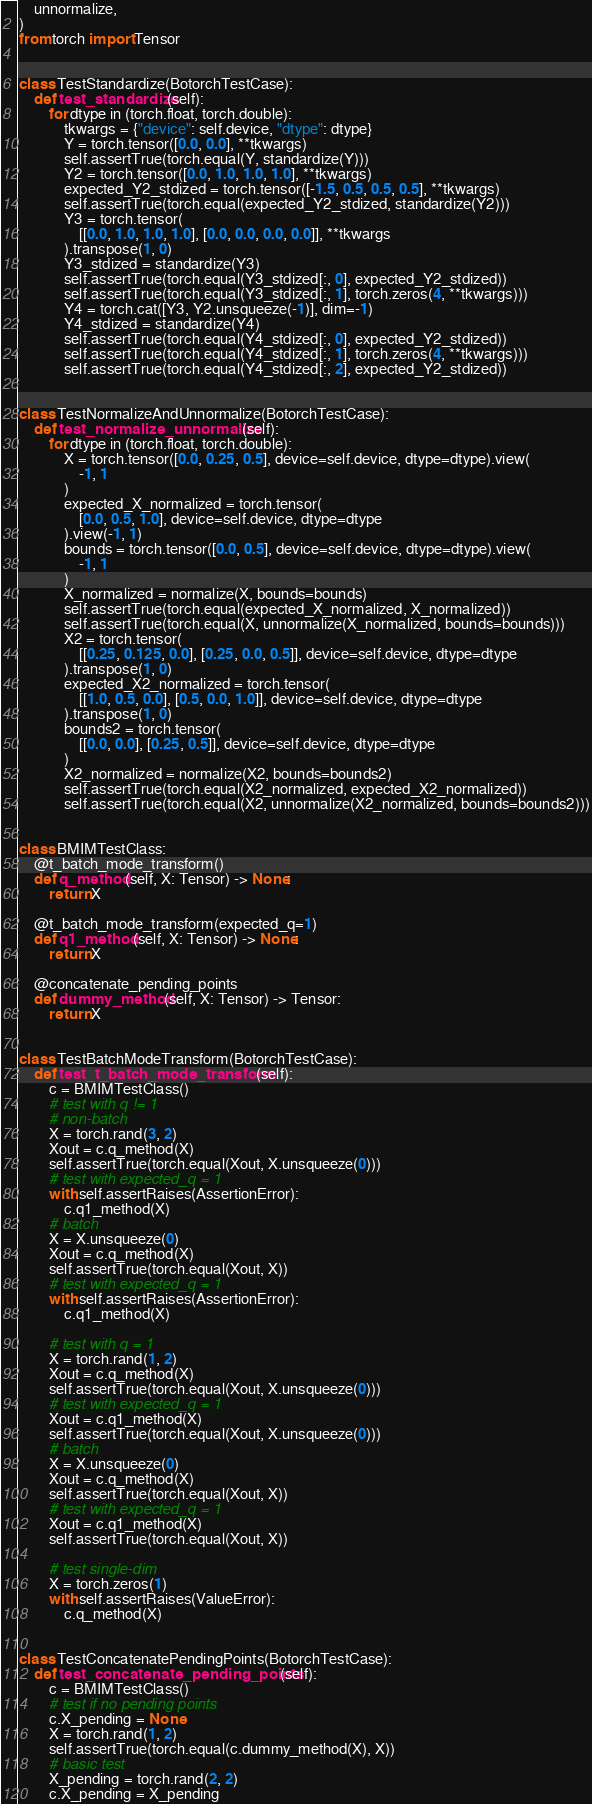Convert code to text. <code><loc_0><loc_0><loc_500><loc_500><_Python_>    unnormalize,
)
from torch import Tensor


class TestStandardize(BotorchTestCase):
    def test_standardize(self):
        for dtype in (torch.float, torch.double):
            tkwargs = {"device": self.device, "dtype": dtype}
            Y = torch.tensor([0.0, 0.0], **tkwargs)
            self.assertTrue(torch.equal(Y, standardize(Y)))
            Y2 = torch.tensor([0.0, 1.0, 1.0, 1.0], **tkwargs)
            expected_Y2_stdized = torch.tensor([-1.5, 0.5, 0.5, 0.5], **tkwargs)
            self.assertTrue(torch.equal(expected_Y2_stdized, standardize(Y2)))
            Y3 = torch.tensor(
                [[0.0, 1.0, 1.0, 1.0], [0.0, 0.0, 0.0, 0.0]], **tkwargs
            ).transpose(1, 0)
            Y3_stdized = standardize(Y3)
            self.assertTrue(torch.equal(Y3_stdized[:, 0], expected_Y2_stdized))
            self.assertTrue(torch.equal(Y3_stdized[:, 1], torch.zeros(4, **tkwargs)))
            Y4 = torch.cat([Y3, Y2.unsqueeze(-1)], dim=-1)
            Y4_stdized = standardize(Y4)
            self.assertTrue(torch.equal(Y4_stdized[:, 0], expected_Y2_stdized))
            self.assertTrue(torch.equal(Y4_stdized[:, 1], torch.zeros(4, **tkwargs)))
            self.assertTrue(torch.equal(Y4_stdized[:, 2], expected_Y2_stdized))


class TestNormalizeAndUnnormalize(BotorchTestCase):
    def test_normalize_unnormalize(self):
        for dtype in (torch.float, torch.double):
            X = torch.tensor([0.0, 0.25, 0.5], device=self.device, dtype=dtype).view(
                -1, 1
            )
            expected_X_normalized = torch.tensor(
                [0.0, 0.5, 1.0], device=self.device, dtype=dtype
            ).view(-1, 1)
            bounds = torch.tensor([0.0, 0.5], device=self.device, dtype=dtype).view(
                -1, 1
            )
            X_normalized = normalize(X, bounds=bounds)
            self.assertTrue(torch.equal(expected_X_normalized, X_normalized))
            self.assertTrue(torch.equal(X, unnormalize(X_normalized, bounds=bounds)))
            X2 = torch.tensor(
                [[0.25, 0.125, 0.0], [0.25, 0.0, 0.5]], device=self.device, dtype=dtype
            ).transpose(1, 0)
            expected_X2_normalized = torch.tensor(
                [[1.0, 0.5, 0.0], [0.5, 0.0, 1.0]], device=self.device, dtype=dtype
            ).transpose(1, 0)
            bounds2 = torch.tensor(
                [[0.0, 0.0], [0.25, 0.5]], device=self.device, dtype=dtype
            )
            X2_normalized = normalize(X2, bounds=bounds2)
            self.assertTrue(torch.equal(X2_normalized, expected_X2_normalized))
            self.assertTrue(torch.equal(X2, unnormalize(X2_normalized, bounds=bounds2)))


class BMIMTestClass:
    @t_batch_mode_transform()
    def q_method(self, X: Tensor) -> None:
        return X

    @t_batch_mode_transform(expected_q=1)
    def q1_method(self, X: Tensor) -> None:
        return X

    @concatenate_pending_points
    def dummy_method(self, X: Tensor) -> Tensor:
        return X


class TestBatchModeTransform(BotorchTestCase):
    def test_t_batch_mode_transform(self):
        c = BMIMTestClass()
        # test with q != 1
        # non-batch
        X = torch.rand(3, 2)
        Xout = c.q_method(X)
        self.assertTrue(torch.equal(Xout, X.unsqueeze(0)))
        # test with expected_q = 1
        with self.assertRaises(AssertionError):
            c.q1_method(X)
        # batch
        X = X.unsqueeze(0)
        Xout = c.q_method(X)
        self.assertTrue(torch.equal(Xout, X))
        # test with expected_q = 1
        with self.assertRaises(AssertionError):
            c.q1_method(X)

        # test with q = 1
        X = torch.rand(1, 2)
        Xout = c.q_method(X)
        self.assertTrue(torch.equal(Xout, X.unsqueeze(0)))
        # test with expected_q = 1
        Xout = c.q1_method(X)
        self.assertTrue(torch.equal(Xout, X.unsqueeze(0)))
        # batch
        X = X.unsqueeze(0)
        Xout = c.q_method(X)
        self.assertTrue(torch.equal(Xout, X))
        # test with expected_q = 1
        Xout = c.q1_method(X)
        self.assertTrue(torch.equal(Xout, X))

        # test single-dim
        X = torch.zeros(1)
        with self.assertRaises(ValueError):
            c.q_method(X)


class TestConcatenatePendingPoints(BotorchTestCase):
    def test_concatenate_pending_points(self):
        c = BMIMTestClass()
        # test if no pending points
        c.X_pending = None
        X = torch.rand(1, 2)
        self.assertTrue(torch.equal(c.dummy_method(X), X))
        # basic test
        X_pending = torch.rand(2, 2)
        c.X_pending = X_pending</code> 